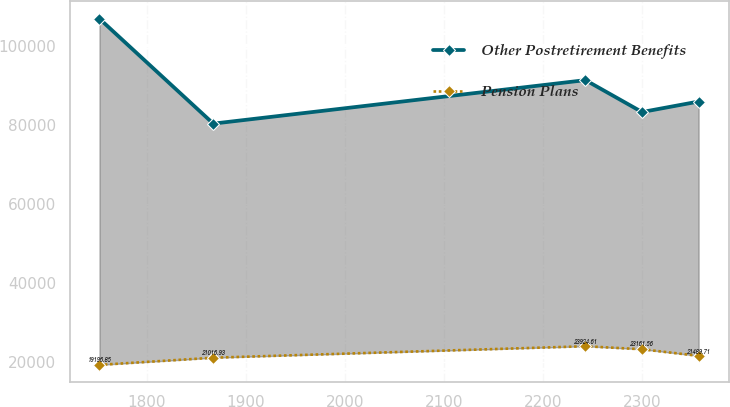Convert chart to OTSL. <chart><loc_0><loc_0><loc_500><loc_500><line_chart><ecel><fcel>Other Postretirement Benefits<fcel>Pension Plans<nl><fcel>1752.16<fcel>107018<fcel>19196.8<nl><fcel>1867.02<fcel>80410.2<fcel>21016.9<nl><fcel>2242.61<fcel>91447.9<fcel>23924.6<nl><fcel>2299.73<fcel>83353.9<fcel>23161.6<nl><fcel>2356.85<fcel>86014.7<fcel>21489.7<nl></chart> 